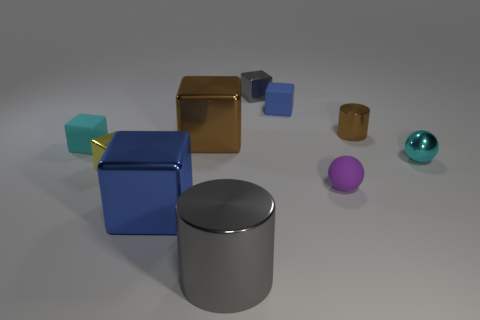What is the size of the cube that is the same color as the tiny cylinder?
Provide a short and direct response. Large. There is a tiny metallic ball; does it have the same color as the matte block in front of the small brown shiny cylinder?
Offer a terse response. Yes. How many other objects are the same size as the blue rubber thing?
Offer a terse response. 6. Does the cyan rubber object have the same size as the metal cylinder that is on the left side of the purple matte object?
Your answer should be very brief. No. Is the size of the matte object left of the blue rubber thing the same as the blue metal object in front of the tiny metallic sphere?
Offer a terse response. No. How many balls are the same material as the gray cylinder?
Provide a short and direct response. 1. Is the shape of the small brown object the same as the big brown shiny thing?
Offer a terse response. No. There is a cylinder that is right of the metallic cylinder that is in front of the tiny cyan metallic thing that is behind the big blue cube; how big is it?
Offer a terse response. Small. There is a large metallic cube that is in front of the small purple sphere; are there any balls that are right of it?
Your answer should be very brief. Yes. There is a matte block on the right side of the large thing to the right of the big brown block; what number of small yellow things are to the right of it?
Your answer should be very brief. 0. 